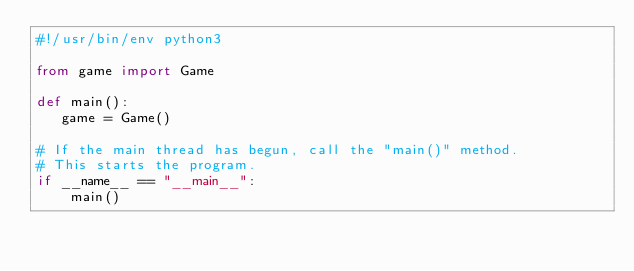Convert code to text. <code><loc_0><loc_0><loc_500><loc_500><_Python_>#!/usr/bin/env python3

from game import Game

def main():
   game = Game() 

# If the main thread has begun, call the "main()" method.
# This starts the program.
if __name__ == "__main__":
    main()
</code> 